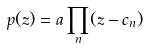Convert formula to latex. <formula><loc_0><loc_0><loc_500><loc_500>p ( z ) = a \prod _ { n } ( z - c _ { n } )</formula> 